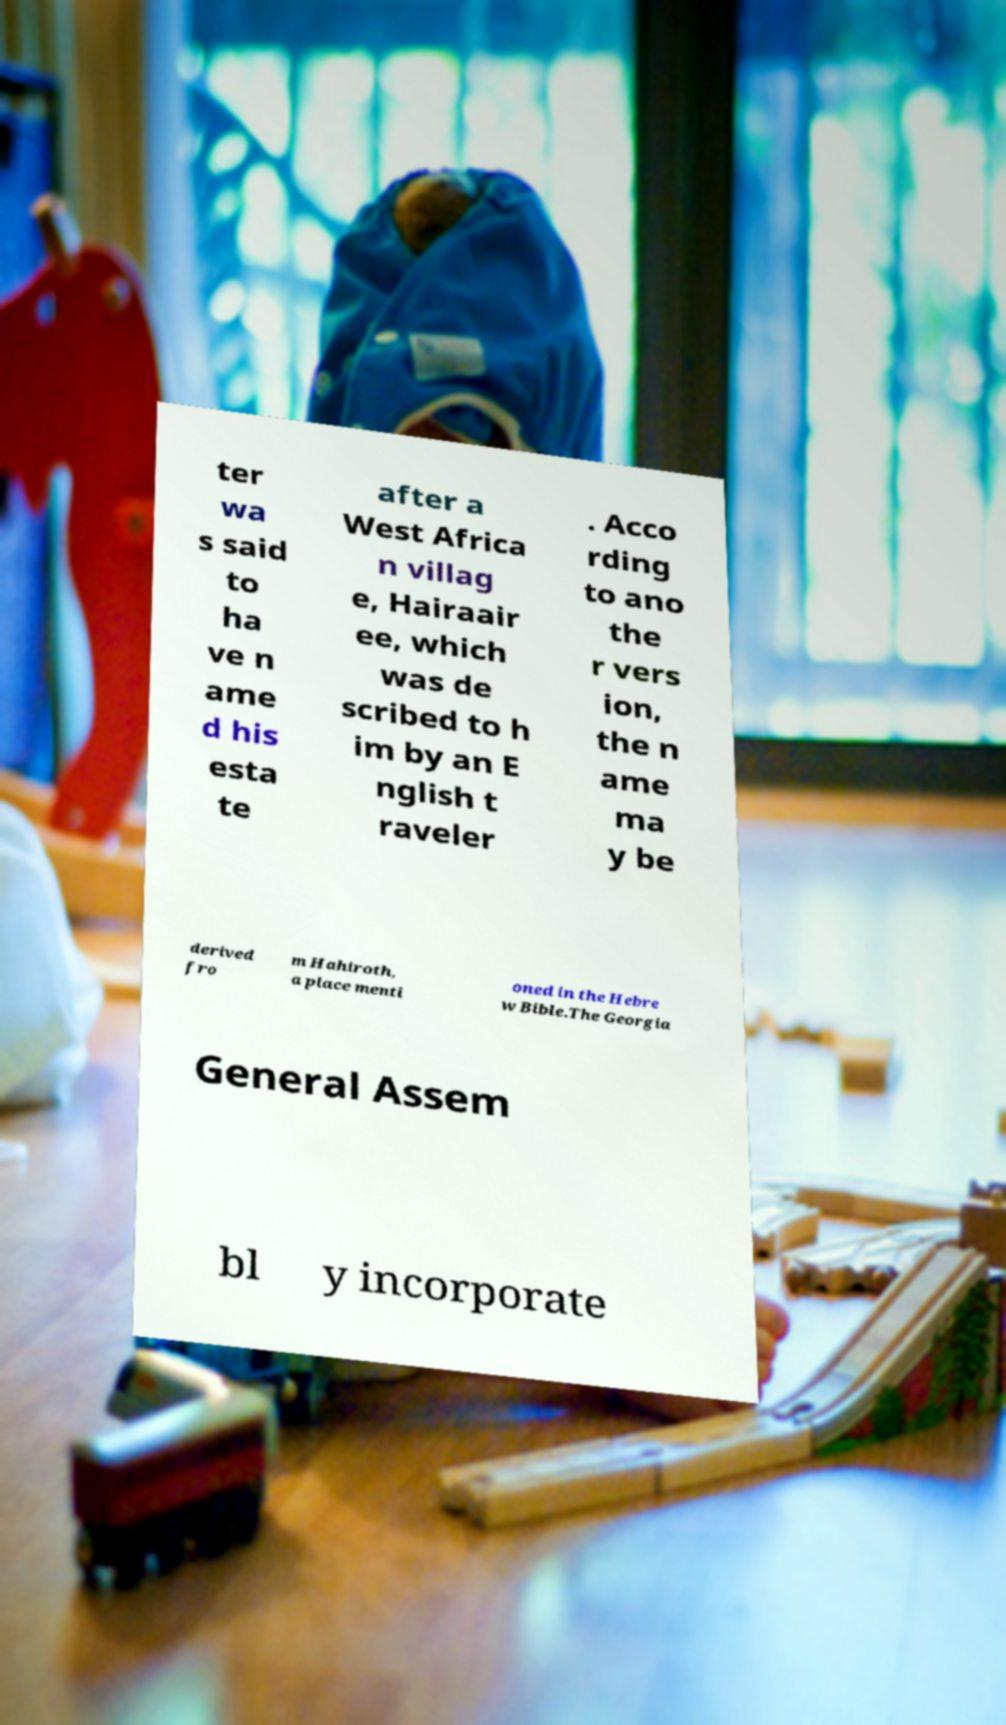There's text embedded in this image that I need extracted. Can you transcribe it verbatim? ter wa s said to ha ve n ame d his esta te after a West Africa n villag e, Hairaair ee, which was de scribed to h im by an E nglish t raveler . Acco rding to ano the r vers ion, the n ame ma y be derived fro m Hahiroth, a place menti oned in the Hebre w Bible.The Georgia General Assem bl y incorporate 